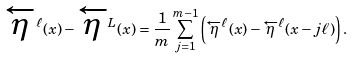Convert formula to latex. <formula><loc_0><loc_0><loc_500><loc_500>\overleftarrow { \eta } ^ { \ell } ( x ) - \overleftarrow { \eta } ^ { L } ( x ) & = \frac { 1 } { m } \sum _ { j = 1 } ^ { m - 1 } \left ( \overleftarrow { \eta } ^ { \ell } ( x ) - \overleftarrow { \eta } ^ { \ell } ( x - j \ell ) \right ) .</formula> 